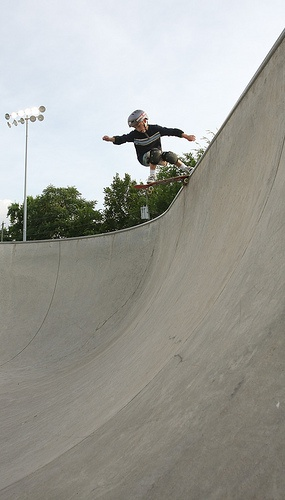Describe the objects in this image and their specific colors. I can see people in lightgray, black, gray, white, and darkgray tones and skateboard in lightgray, maroon, black, and gray tones in this image. 